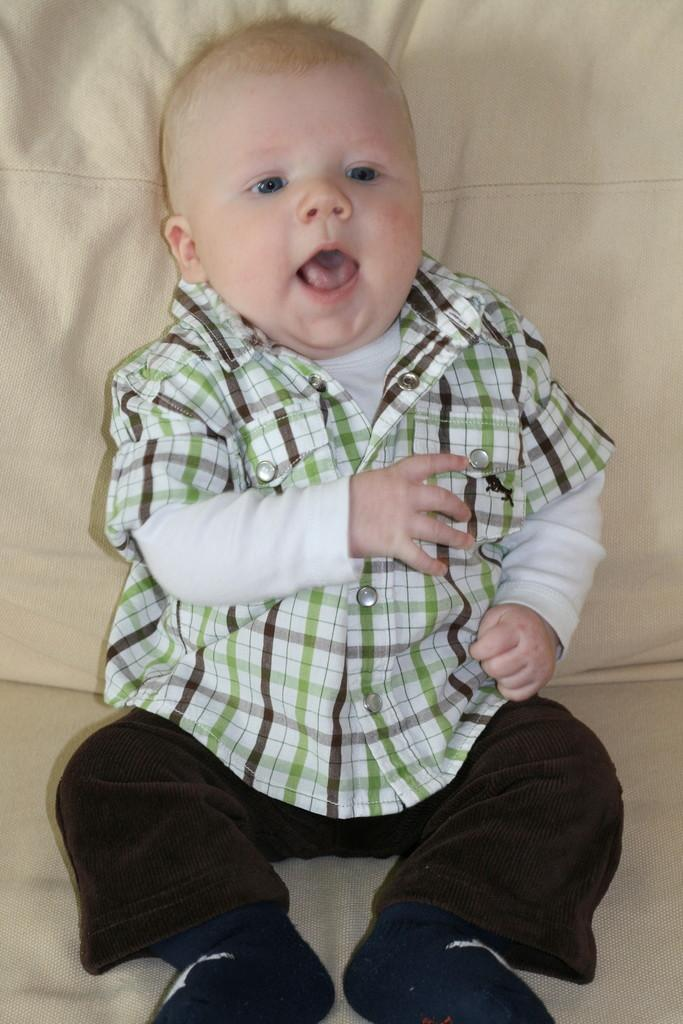What is the main subject of the image? The main subject of the image is a baby. Where is the baby located in the image? The baby is sitting on a couch. What type of boundary can be seen in the image? There is no boundary present in the image; it features a baby sitting on a couch. What type of work is the baby doing in the image? The baby is not working in the image; they are simply sitting on a couch. 